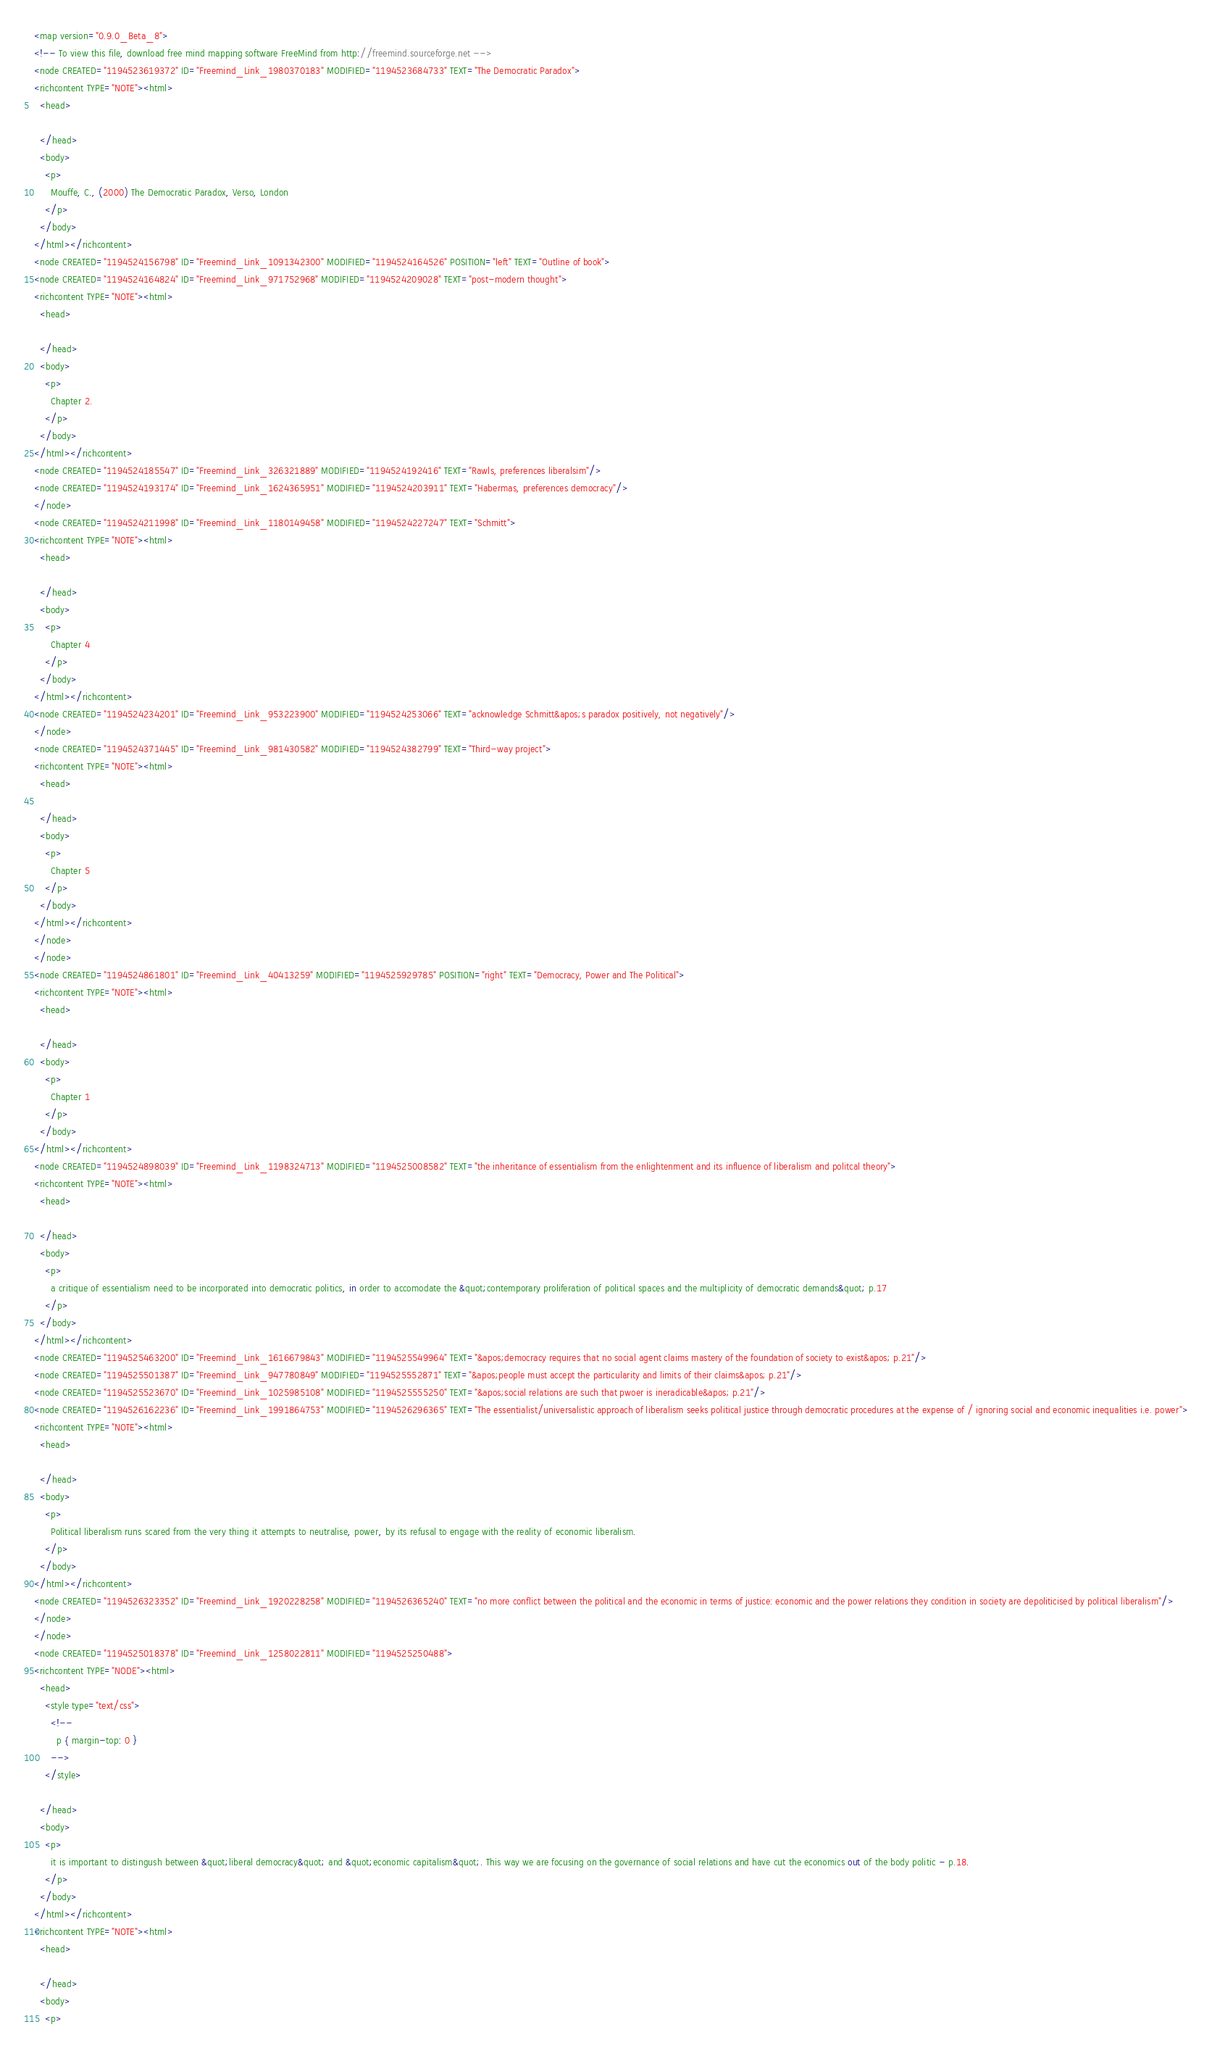<code> <loc_0><loc_0><loc_500><loc_500><_ObjectiveC_><map version="0.9.0_Beta_8">
<!-- To view this file, download free mind mapping software FreeMind from http://freemind.sourceforge.net -->
<node CREATED="1194523619372" ID="Freemind_Link_1980370183" MODIFIED="1194523684733" TEXT="The Democratic Paradox">
<richcontent TYPE="NOTE"><html>
  <head>
    
  </head>
  <body>
    <p>
      Mouffe, C., (2000) The Democratic Paradox, Verso, London
    </p>
  </body>
</html></richcontent>
<node CREATED="1194524156798" ID="Freemind_Link_1091342300" MODIFIED="1194524164526" POSITION="left" TEXT="Outline of book">
<node CREATED="1194524164824" ID="Freemind_Link_971752968" MODIFIED="1194524209028" TEXT="post-modern thought">
<richcontent TYPE="NOTE"><html>
  <head>
    
  </head>
  <body>
    <p>
      Chapter 2.
    </p>
  </body>
</html></richcontent>
<node CREATED="1194524185547" ID="Freemind_Link_326321889" MODIFIED="1194524192416" TEXT="Rawls, preferences liberalsim"/>
<node CREATED="1194524193174" ID="Freemind_Link_1624365951" MODIFIED="1194524203911" TEXT="Habermas, preferences democracy"/>
</node>
<node CREATED="1194524211998" ID="Freemind_Link_1180149458" MODIFIED="1194524227247" TEXT="Schmitt">
<richcontent TYPE="NOTE"><html>
  <head>
    
  </head>
  <body>
    <p>
      Chapter 4
    </p>
  </body>
</html></richcontent>
<node CREATED="1194524234201" ID="Freemind_Link_953223900" MODIFIED="1194524253066" TEXT="acknowledge Schmitt&apos;s paradox positively, not negatively"/>
</node>
<node CREATED="1194524371445" ID="Freemind_Link_981430582" MODIFIED="1194524382799" TEXT="Third-way project">
<richcontent TYPE="NOTE"><html>
  <head>
    
  </head>
  <body>
    <p>
      Chapter 5
    </p>
  </body>
</html></richcontent>
</node>
</node>
<node CREATED="1194524861801" ID="Freemind_Link_40413259" MODIFIED="1194525929785" POSITION="right" TEXT="Democracy, Power and The Political">
<richcontent TYPE="NOTE"><html>
  <head>
    
  </head>
  <body>
    <p>
      Chapter 1
    </p>
  </body>
</html></richcontent>
<node CREATED="1194524898039" ID="Freemind_Link_1198324713" MODIFIED="1194525008582" TEXT="the inheritance of essentialism from the enlightenment and its influence of liberalism and politcal theory">
<richcontent TYPE="NOTE"><html>
  <head>
    
  </head>
  <body>
    <p>
      a critique of essentialism need to be incorporated into democratic politics, in order to accomodate the &quot;contemporary proliferation of political spaces and the multiplicity of democratic demands&quot; p.17
    </p>
  </body>
</html></richcontent>
<node CREATED="1194525463200" ID="Freemind_Link_1616679843" MODIFIED="1194525549964" TEXT="&apos;democracy requires that no social agent claims mastery of the foundation of society to exist&apos; p.21"/>
<node CREATED="1194525501387" ID="Freemind_Link_947780849" MODIFIED="1194525552871" TEXT="&apos;people must accept the particularity and limits of their claims&apos; p.21"/>
<node CREATED="1194525523670" ID="Freemind_Link_1025985108" MODIFIED="1194525555250" TEXT="&apos;social relations are such that pwoer is ineradicable&apos; p.21"/>
<node CREATED="1194526162236" ID="Freemind_Link_1991864753" MODIFIED="1194526296365" TEXT="The essentialist/universalistic approach of liberalism seeks political justice through democratic procedures at the expense of / ignoring social and economic inequalities i.e. power">
<richcontent TYPE="NOTE"><html>
  <head>
    
  </head>
  <body>
    <p>
      Political liberalism runs scared from the very thing it attempts to neutralise, power, by its refusal to engage with the reality of economic liberalism.
    </p>
  </body>
</html></richcontent>
<node CREATED="1194526323352" ID="Freemind_Link_1920228258" MODIFIED="1194526365240" TEXT="no more conflict between the political and the economic in terms of justice: economic and the power relations they condition in society are depoliticised by political liberalism"/>
</node>
</node>
<node CREATED="1194525018378" ID="Freemind_Link_1258022811" MODIFIED="1194525250488">
<richcontent TYPE="NODE"><html>
  <head>
    <style type="text/css">
      <!--
        p { margin-top: 0 }
      -->
    </style>
        
  </head>
  <body>
    <p>
      it is important to distingush between &quot;liberal democracy&quot; and &quot;economic capitalism&quot;. This way we are focusing on the governance of social relations and have cut the economics out of the body politic - p.18.
    </p>
  </body>
</html></richcontent>
<richcontent TYPE="NOTE"><html>
  <head>
    
  </head>
  <body>
    <p></code> 